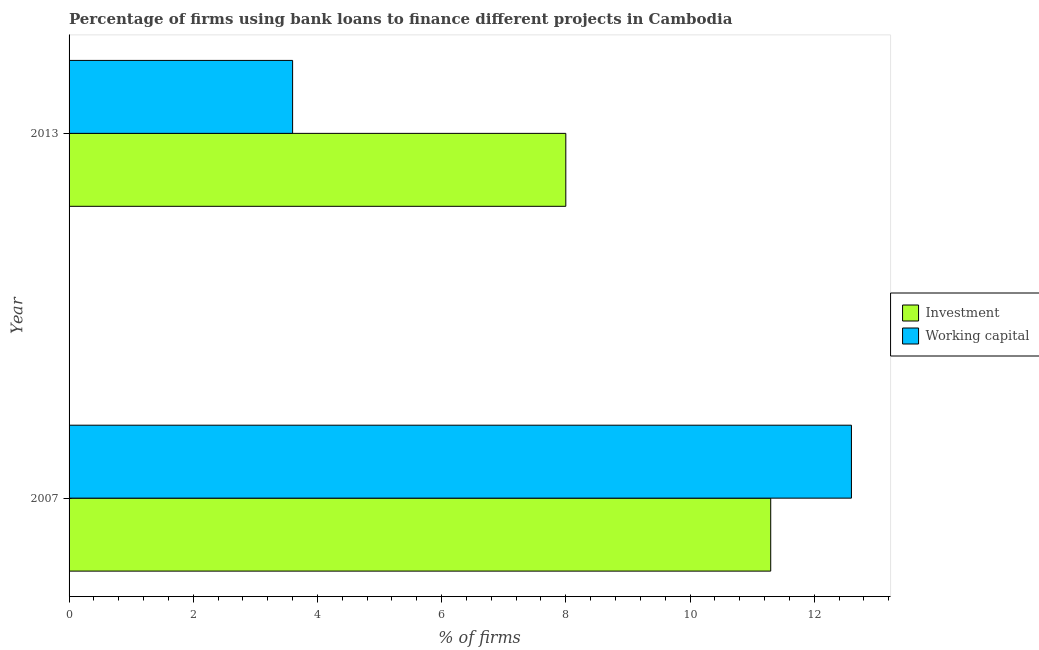How many different coloured bars are there?
Keep it short and to the point. 2. How many groups of bars are there?
Your response must be concise. 2. Are the number of bars per tick equal to the number of legend labels?
Your answer should be very brief. Yes. Are the number of bars on each tick of the Y-axis equal?
Keep it short and to the point. Yes. How many bars are there on the 1st tick from the top?
Your answer should be compact. 2. What is the label of the 1st group of bars from the top?
Offer a very short reply. 2013. Across all years, what is the maximum percentage of firms using banks to finance investment?
Provide a succinct answer. 11.3. In which year was the percentage of firms using banks to finance investment maximum?
Your response must be concise. 2007. What is the total percentage of firms using banks to finance investment in the graph?
Provide a succinct answer. 19.3. What is the difference between the percentage of firms using banks to finance working capital in 2013 and the percentage of firms using banks to finance investment in 2007?
Your answer should be very brief. -7.7. What is the average percentage of firms using banks to finance investment per year?
Give a very brief answer. 9.65. In the year 2007, what is the difference between the percentage of firms using banks to finance working capital and percentage of firms using banks to finance investment?
Your response must be concise. 1.3. What is the ratio of the percentage of firms using banks to finance investment in 2007 to that in 2013?
Provide a succinct answer. 1.41. Is the percentage of firms using banks to finance working capital in 2007 less than that in 2013?
Your answer should be very brief. No. Is the difference between the percentage of firms using banks to finance investment in 2007 and 2013 greater than the difference between the percentage of firms using banks to finance working capital in 2007 and 2013?
Provide a short and direct response. No. What does the 1st bar from the top in 2013 represents?
Ensure brevity in your answer.  Working capital. What does the 2nd bar from the bottom in 2013 represents?
Keep it short and to the point. Working capital. How many bars are there?
Your response must be concise. 4. How many years are there in the graph?
Give a very brief answer. 2. What is the difference between two consecutive major ticks on the X-axis?
Give a very brief answer. 2. Does the graph contain grids?
Your answer should be very brief. No. How many legend labels are there?
Make the answer very short. 2. What is the title of the graph?
Your answer should be very brief. Percentage of firms using bank loans to finance different projects in Cambodia. What is the label or title of the X-axis?
Provide a succinct answer. % of firms. What is the % of firms in Working capital in 2013?
Your answer should be compact. 3.6. What is the total % of firms in Investment in the graph?
Your answer should be compact. 19.3. What is the difference between the % of firms of Investment in 2007 and the % of firms of Working capital in 2013?
Provide a short and direct response. 7.7. What is the average % of firms of Investment per year?
Your response must be concise. 9.65. In the year 2007, what is the difference between the % of firms of Investment and % of firms of Working capital?
Make the answer very short. -1.3. What is the ratio of the % of firms in Investment in 2007 to that in 2013?
Provide a succinct answer. 1.41. What is the ratio of the % of firms of Working capital in 2007 to that in 2013?
Your answer should be compact. 3.5. What is the difference between the highest and the second highest % of firms of Investment?
Ensure brevity in your answer.  3.3. What is the difference between the highest and the second highest % of firms in Working capital?
Give a very brief answer. 9. What is the difference between the highest and the lowest % of firms in Investment?
Your response must be concise. 3.3. 